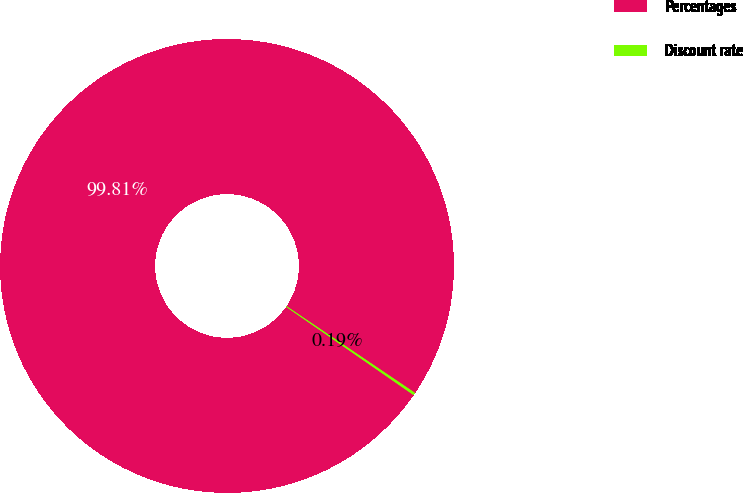<chart> <loc_0><loc_0><loc_500><loc_500><pie_chart><fcel>Percentages<fcel>Discount rate<nl><fcel>99.81%<fcel>0.19%<nl></chart> 